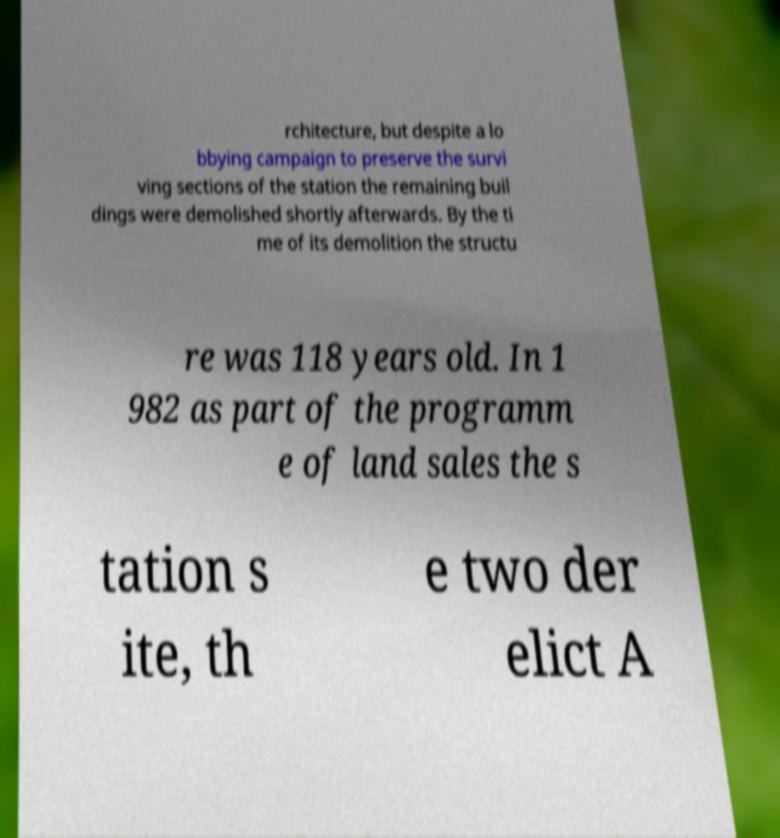Please read and relay the text visible in this image. What does it say? rchitecture, but despite a lo bbying campaign to preserve the survi ving sections of the station the remaining buil dings were demolished shortly afterwards. By the ti me of its demolition the structu re was 118 years old. In 1 982 as part of the programm e of land sales the s tation s ite, th e two der elict A 